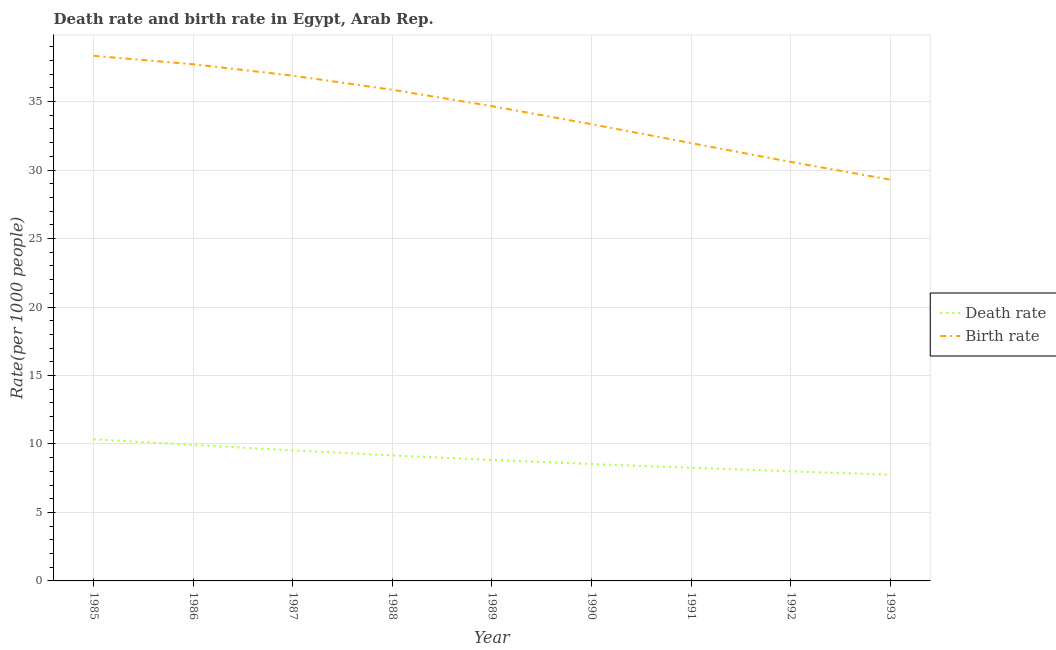Does the line corresponding to death rate intersect with the line corresponding to birth rate?
Make the answer very short. No. What is the birth rate in 1986?
Ensure brevity in your answer.  37.73. Across all years, what is the maximum death rate?
Provide a short and direct response. 10.34. Across all years, what is the minimum birth rate?
Give a very brief answer. 29.3. What is the total birth rate in the graph?
Offer a terse response. 308.69. What is the difference between the death rate in 1986 and that in 1990?
Your answer should be very brief. 1.39. What is the difference between the death rate in 1989 and the birth rate in 1985?
Your answer should be compact. -29.51. What is the average birth rate per year?
Give a very brief answer. 34.3. In the year 1992, what is the difference between the death rate and birth rate?
Offer a very short reply. -22.59. In how many years, is the death rate greater than 36?
Keep it short and to the point. 0. What is the ratio of the birth rate in 1991 to that in 1993?
Give a very brief answer. 1.09. Is the death rate in 1990 less than that in 1992?
Offer a very short reply. No. Is the difference between the birth rate in 1986 and 1991 greater than the difference between the death rate in 1986 and 1991?
Offer a terse response. Yes. What is the difference between the highest and the second highest birth rate?
Provide a short and direct response. 0.62. What is the difference between the highest and the lowest birth rate?
Keep it short and to the point. 9.05. Is the sum of the death rate in 1989 and 1993 greater than the maximum birth rate across all years?
Offer a very short reply. No. Does the death rate monotonically increase over the years?
Your answer should be compact. No. Is the death rate strictly greater than the birth rate over the years?
Offer a terse response. No. Does the graph contain any zero values?
Make the answer very short. No. Does the graph contain grids?
Keep it short and to the point. Yes. How many legend labels are there?
Provide a succinct answer. 2. What is the title of the graph?
Offer a very short reply. Death rate and birth rate in Egypt, Arab Rep. What is the label or title of the Y-axis?
Offer a very short reply. Rate(per 1000 people). What is the Rate(per 1000 people) in Death rate in 1985?
Your answer should be compact. 10.34. What is the Rate(per 1000 people) in Birth rate in 1985?
Offer a very short reply. 38.34. What is the Rate(per 1000 people) of Death rate in 1986?
Keep it short and to the point. 9.93. What is the Rate(per 1000 people) of Birth rate in 1986?
Your response must be concise. 37.73. What is the Rate(per 1000 people) in Death rate in 1987?
Offer a very short reply. 9.53. What is the Rate(per 1000 people) of Birth rate in 1987?
Your answer should be very brief. 36.89. What is the Rate(per 1000 people) in Death rate in 1988?
Provide a short and direct response. 9.16. What is the Rate(per 1000 people) of Birth rate in 1988?
Your answer should be compact. 35.86. What is the Rate(per 1000 people) of Death rate in 1989?
Provide a short and direct response. 8.83. What is the Rate(per 1000 people) of Birth rate in 1989?
Provide a short and direct response. 34.67. What is the Rate(per 1000 people) in Death rate in 1990?
Your answer should be compact. 8.54. What is the Rate(per 1000 people) of Birth rate in 1990?
Ensure brevity in your answer.  33.35. What is the Rate(per 1000 people) in Death rate in 1991?
Keep it short and to the point. 8.26. What is the Rate(per 1000 people) in Birth rate in 1991?
Your response must be concise. 31.97. What is the Rate(per 1000 people) in Death rate in 1992?
Keep it short and to the point. 8.01. What is the Rate(per 1000 people) of Birth rate in 1992?
Offer a very short reply. 30.59. What is the Rate(per 1000 people) of Death rate in 1993?
Make the answer very short. 7.75. What is the Rate(per 1000 people) of Birth rate in 1993?
Your answer should be compact. 29.3. Across all years, what is the maximum Rate(per 1000 people) in Death rate?
Keep it short and to the point. 10.34. Across all years, what is the maximum Rate(per 1000 people) in Birth rate?
Offer a very short reply. 38.34. Across all years, what is the minimum Rate(per 1000 people) of Death rate?
Offer a very short reply. 7.75. Across all years, what is the minimum Rate(per 1000 people) of Birth rate?
Ensure brevity in your answer.  29.3. What is the total Rate(per 1000 people) of Death rate in the graph?
Keep it short and to the point. 80.36. What is the total Rate(per 1000 people) of Birth rate in the graph?
Ensure brevity in your answer.  308.69. What is the difference between the Rate(per 1000 people) of Death rate in 1985 and that in 1986?
Your answer should be very brief. 0.41. What is the difference between the Rate(per 1000 people) of Birth rate in 1985 and that in 1986?
Offer a very short reply. 0.62. What is the difference between the Rate(per 1000 people) in Death rate in 1985 and that in 1987?
Keep it short and to the point. 0.81. What is the difference between the Rate(per 1000 people) in Birth rate in 1985 and that in 1987?
Offer a terse response. 1.45. What is the difference between the Rate(per 1000 people) of Death rate in 1985 and that in 1988?
Your response must be concise. 1.18. What is the difference between the Rate(per 1000 people) of Birth rate in 1985 and that in 1988?
Provide a succinct answer. 2.48. What is the difference between the Rate(per 1000 people) in Death rate in 1985 and that in 1989?
Give a very brief answer. 1.51. What is the difference between the Rate(per 1000 people) in Birth rate in 1985 and that in 1989?
Provide a succinct answer. 3.68. What is the difference between the Rate(per 1000 people) of Death rate in 1985 and that in 1990?
Your answer should be compact. 1.8. What is the difference between the Rate(per 1000 people) in Birth rate in 1985 and that in 1990?
Offer a terse response. 4.99. What is the difference between the Rate(per 1000 people) in Death rate in 1985 and that in 1991?
Your answer should be very brief. 2.08. What is the difference between the Rate(per 1000 people) of Birth rate in 1985 and that in 1991?
Keep it short and to the point. 6.38. What is the difference between the Rate(per 1000 people) of Death rate in 1985 and that in 1992?
Your answer should be compact. 2.33. What is the difference between the Rate(per 1000 people) in Birth rate in 1985 and that in 1992?
Offer a terse response. 7.75. What is the difference between the Rate(per 1000 people) in Death rate in 1985 and that in 1993?
Your answer should be very brief. 2.58. What is the difference between the Rate(per 1000 people) of Birth rate in 1985 and that in 1993?
Provide a succinct answer. 9.05. What is the difference between the Rate(per 1000 people) in Death rate in 1986 and that in 1987?
Give a very brief answer. 0.4. What is the difference between the Rate(per 1000 people) of Birth rate in 1986 and that in 1987?
Provide a short and direct response. 0.83. What is the difference between the Rate(per 1000 people) of Death rate in 1986 and that in 1988?
Offer a very short reply. 0.76. What is the difference between the Rate(per 1000 people) of Birth rate in 1986 and that in 1988?
Your response must be concise. 1.86. What is the difference between the Rate(per 1000 people) in Death rate in 1986 and that in 1989?
Ensure brevity in your answer.  1.09. What is the difference between the Rate(per 1000 people) of Birth rate in 1986 and that in 1989?
Your answer should be very brief. 3.06. What is the difference between the Rate(per 1000 people) of Death rate in 1986 and that in 1990?
Ensure brevity in your answer.  1.39. What is the difference between the Rate(per 1000 people) in Birth rate in 1986 and that in 1990?
Provide a succinct answer. 4.38. What is the difference between the Rate(per 1000 people) in Death rate in 1986 and that in 1991?
Your answer should be very brief. 1.66. What is the difference between the Rate(per 1000 people) in Birth rate in 1986 and that in 1991?
Your response must be concise. 5.76. What is the difference between the Rate(per 1000 people) of Death rate in 1986 and that in 1992?
Ensure brevity in your answer.  1.92. What is the difference between the Rate(per 1000 people) of Birth rate in 1986 and that in 1992?
Ensure brevity in your answer.  7.13. What is the difference between the Rate(per 1000 people) of Death rate in 1986 and that in 1993?
Offer a very short reply. 2.17. What is the difference between the Rate(per 1000 people) of Birth rate in 1986 and that in 1993?
Offer a very short reply. 8.43. What is the difference between the Rate(per 1000 people) in Death rate in 1987 and that in 1988?
Provide a succinct answer. 0.37. What is the difference between the Rate(per 1000 people) of Death rate in 1987 and that in 1989?
Your answer should be very brief. 0.7. What is the difference between the Rate(per 1000 people) in Birth rate in 1987 and that in 1989?
Make the answer very short. 2.23. What is the difference between the Rate(per 1000 people) in Death rate in 1987 and that in 1990?
Your answer should be very brief. 0.99. What is the difference between the Rate(per 1000 people) in Birth rate in 1987 and that in 1990?
Offer a very short reply. 3.54. What is the difference between the Rate(per 1000 people) in Death rate in 1987 and that in 1991?
Your answer should be very brief. 1.27. What is the difference between the Rate(per 1000 people) of Birth rate in 1987 and that in 1991?
Your response must be concise. 4.92. What is the difference between the Rate(per 1000 people) in Death rate in 1987 and that in 1992?
Offer a very short reply. 1.53. What is the difference between the Rate(per 1000 people) in Birth rate in 1987 and that in 1992?
Provide a short and direct response. 6.3. What is the difference between the Rate(per 1000 people) of Death rate in 1987 and that in 1993?
Provide a succinct answer. 1.78. What is the difference between the Rate(per 1000 people) in Birth rate in 1987 and that in 1993?
Provide a succinct answer. 7.6. What is the difference between the Rate(per 1000 people) of Death rate in 1988 and that in 1989?
Ensure brevity in your answer.  0.33. What is the difference between the Rate(per 1000 people) in Birth rate in 1988 and that in 1989?
Provide a short and direct response. 1.2. What is the difference between the Rate(per 1000 people) in Death rate in 1988 and that in 1990?
Provide a short and direct response. 0.63. What is the difference between the Rate(per 1000 people) of Birth rate in 1988 and that in 1990?
Your response must be concise. 2.51. What is the difference between the Rate(per 1000 people) in Death rate in 1988 and that in 1991?
Provide a succinct answer. 0.9. What is the difference between the Rate(per 1000 people) in Birth rate in 1988 and that in 1991?
Offer a very short reply. 3.9. What is the difference between the Rate(per 1000 people) in Death rate in 1988 and that in 1992?
Keep it short and to the point. 1.16. What is the difference between the Rate(per 1000 people) of Birth rate in 1988 and that in 1992?
Offer a very short reply. 5.27. What is the difference between the Rate(per 1000 people) of Death rate in 1988 and that in 1993?
Provide a succinct answer. 1.41. What is the difference between the Rate(per 1000 people) in Birth rate in 1988 and that in 1993?
Make the answer very short. 6.57. What is the difference between the Rate(per 1000 people) in Death rate in 1989 and that in 1990?
Provide a succinct answer. 0.3. What is the difference between the Rate(per 1000 people) of Birth rate in 1989 and that in 1990?
Keep it short and to the point. 1.32. What is the difference between the Rate(per 1000 people) of Death rate in 1989 and that in 1991?
Your answer should be very brief. 0.57. What is the difference between the Rate(per 1000 people) of Birth rate in 1989 and that in 1991?
Keep it short and to the point. 2.7. What is the difference between the Rate(per 1000 people) in Death rate in 1989 and that in 1992?
Your response must be concise. 0.83. What is the difference between the Rate(per 1000 people) of Birth rate in 1989 and that in 1992?
Ensure brevity in your answer.  4.07. What is the difference between the Rate(per 1000 people) of Death rate in 1989 and that in 1993?
Your response must be concise. 1.08. What is the difference between the Rate(per 1000 people) of Birth rate in 1989 and that in 1993?
Make the answer very short. 5.37. What is the difference between the Rate(per 1000 people) in Death rate in 1990 and that in 1991?
Provide a succinct answer. 0.27. What is the difference between the Rate(per 1000 people) of Birth rate in 1990 and that in 1991?
Give a very brief answer. 1.38. What is the difference between the Rate(per 1000 people) of Death rate in 1990 and that in 1992?
Your answer should be compact. 0.53. What is the difference between the Rate(per 1000 people) in Birth rate in 1990 and that in 1992?
Give a very brief answer. 2.75. What is the difference between the Rate(per 1000 people) of Death rate in 1990 and that in 1993?
Your response must be concise. 0.78. What is the difference between the Rate(per 1000 people) in Birth rate in 1990 and that in 1993?
Provide a succinct answer. 4.05. What is the difference between the Rate(per 1000 people) of Death rate in 1991 and that in 1992?
Offer a terse response. 0.26. What is the difference between the Rate(per 1000 people) of Birth rate in 1991 and that in 1992?
Give a very brief answer. 1.37. What is the difference between the Rate(per 1000 people) of Death rate in 1991 and that in 1993?
Your answer should be very brief. 0.51. What is the difference between the Rate(per 1000 people) of Birth rate in 1991 and that in 1993?
Your answer should be very brief. 2.67. What is the difference between the Rate(per 1000 people) of Death rate in 1992 and that in 1993?
Make the answer very short. 0.25. What is the difference between the Rate(per 1000 people) of Birth rate in 1992 and that in 1993?
Your answer should be compact. 1.3. What is the difference between the Rate(per 1000 people) of Death rate in 1985 and the Rate(per 1000 people) of Birth rate in 1986?
Offer a very short reply. -27.39. What is the difference between the Rate(per 1000 people) of Death rate in 1985 and the Rate(per 1000 people) of Birth rate in 1987?
Provide a succinct answer. -26.55. What is the difference between the Rate(per 1000 people) of Death rate in 1985 and the Rate(per 1000 people) of Birth rate in 1988?
Your response must be concise. -25.52. What is the difference between the Rate(per 1000 people) of Death rate in 1985 and the Rate(per 1000 people) of Birth rate in 1989?
Provide a short and direct response. -24.33. What is the difference between the Rate(per 1000 people) of Death rate in 1985 and the Rate(per 1000 people) of Birth rate in 1990?
Give a very brief answer. -23.01. What is the difference between the Rate(per 1000 people) of Death rate in 1985 and the Rate(per 1000 people) of Birth rate in 1991?
Your response must be concise. -21.63. What is the difference between the Rate(per 1000 people) of Death rate in 1985 and the Rate(per 1000 people) of Birth rate in 1992?
Keep it short and to the point. -20.25. What is the difference between the Rate(per 1000 people) in Death rate in 1985 and the Rate(per 1000 people) in Birth rate in 1993?
Offer a terse response. -18.96. What is the difference between the Rate(per 1000 people) in Death rate in 1986 and the Rate(per 1000 people) in Birth rate in 1987?
Provide a short and direct response. -26.97. What is the difference between the Rate(per 1000 people) of Death rate in 1986 and the Rate(per 1000 people) of Birth rate in 1988?
Ensure brevity in your answer.  -25.94. What is the difference between the Rate(per 1000 people) of Death rate in 1986 and the Rate(per 1000 people) of Birth rate in 1989?
Your response must be concise. -24.74. What is the difference between the Rate(per 1000 people) of Death rate in 1986 and the Rate(per 1000 people) of Birth rate in 1990?
Offer a very short reply. -23.42. What is the difference between the Rate(per 1000 people) in Death rate in 1986 and the Rate(per 1000 people) in Birth rate in 1991?
Provide a short and direct response. -22.04. What is the difference between the Rate(per 1000 people) of Death rate in 1986 and the Rate(per 1000 people) of Birth rate in 1992?
Your answer should be very brief. -20.67. What is the difference between the Rate(per 1000 people) in Death rate in 1986 and the Rate(per 1000 people) in Birth rate in 1993?
Give a very brief answer. -19.37. What is the difference between the Rate(per 1000 people) of Death rate in 1987 and the Rate(per 1000 people) of Birth rate in 1988?
Ensure brevity in your answer.  -26.33. What is the difference between the Rate(per 1000 people) in Death rate in 1987 and the Rate(per 1000 people) in Birth rate in 1989?
Provide a succinct answer. -25.14. What is the difference between the Rate(per 1000 people) in Death rate in 1987 and the Rate(per 1000 people) in Birth rate in 1990?
Your response must be concise. -23.82. What is the difference between the Rate(per 1000 people) in Death rate in 1987 and the Rate(per 1000 people) in Birth rate in 1991?
Offer a very short reply. -22.44. What is the difference between the Rate(per 1000 people) in Death rate in 1987 and the Rate(per 1000 people) in Birth rate in 1992?
Provide a succinct answer. -21.06. What is the difference between the Rate(per 1000 people) of Death rate in 1987 and the Rate(per 1000 people) of Birth rate in 1993?
Ensure brevity in your answer.  -19.77. What is the difference between the Rate(per 1000 people) of Death rate in 1988 and the Rate(per 1000 people) of Birth rate in 1989?
Your answer should be very brief. -25.5. What is the difference between the Rate(per 1000 people) of Death rate in 1988 and the Rate(per 1000 people) of Birth rate in 1990?
Provide a short and direct response. -24.18. What is the difference between the Rate(per 1000 people) of Death rate in 1988 and the Rate(per 1000 people) of Birth rate in 1991?
Offer a very short reply. -22.8. What is the difference between the Rate(per 1000 people) in Death rate in 1988 and the Rate(per 1000 people) in Birth rate in 1992?
Give a very brief answer. -21.43. What is the difference between the Rate(per 1000 people) of Death rate in 1988 and the Rate(per 1000 people) of Birth rate in 1993?
Provide a short and direct response. -20.13. What is the difference between the Rate(per 1000 people) in Death rate in 1989 and the Rate(per 1000 people) in Birth rate in 1990?
Give a very brief answer. -24.51. What is the difference between the Rate(per 1000 people) in Death rate in 1989 and the Rate(per 1000 people) in Birth rate in 1991?
Provide a short and direct response. -23.13. What is the difference between the Rate(per 1000 people) in Death rate in 1989 and the Rate(per 1000 people) in Birth rate in 1992?
Ensure brevity in your answer.  -21.76. What is the difference between the Rate(per 1000 people) in Death rate in 1989 and the Rate(per 1000 people) in Birth rate in 1993?
Your answer should be very brief. -20.46. What is the difference between the Rate(per 1000 people) of Death rate in 1990 and the Rate(per 1000 people) of Birth rate in 1991?
Ensure brevity in your answer.  -23.43. What is the difference between the Rate(per 1000 people) of Death rate in 1990 and the Rate(per 1000 people) of Birth rate in 1992?
Provide a succinct answer. -22.06. What is the difference between the Rate(per 1000 people) of Death rate in 1990 and the Rate(per 1000 people) of Birth rate in 1993?
Offer a terse response. -20.76. What is the difference between the Rate(per 1000 people) in Death rate in 1991 and the Rate(per 1000 people) in Birth rate in 1992?
Your answer should be very brief. -22.33. What is the difference between the Rate(per 1000 people) of Death rate in 1991 and the Rate(per 1000 people) of Birth rate in 1993?
Give a very brief answer. -21.03. What is the difference between the Rate(per 1000 people) in Death rate in 1992 and the Rate(per 1000 people) in Birth rate in 1993?
Ensure brevity in your answer.  -21.29. What is the average Rate(per 1000 people) of Death rate per year?
Give a very brief answer. 8.93. What is the average Rate(per 1000 people) of Birth rate per year?
Offer a terse response. 34.3. In the year 1985, what is the difference between the Rate(per 1000 people) in Death rate and Rate(per 1000 people) in Birth rate?
Ensure brevity in your answer.  -28. In the year 1986, what is the difference between the Rate(per 1000 people) in Death rate and Rate(per 1000 people) in Birth rate?
Ensure brevity in your answer.  -27.8. In the year 1987, what is the difference between the Rate(per 1000 people) in Death rate and Rate(per 1000 people) in Birth rate?
Offer a very short reply. -27.36. In the year 1988, what is the difference between the Rate(per 1000 people) of Death rate and Rate(per 1000 people) of Birth rate?
Offer a terse response. -26.7. In the year 1989, what is the difference between the Rate(per 1000 people) in Death rate and Rate(per 1000 people) in Birth rate?
Keep it short and to the point. -25.83. In the year 1990, what is the difference between the Rate(per 1000 people) in Death rate and Rate(per 1000 people) in Birth rate?
Your response must be concise. -24.81. In the year 1991, what is the difference between the Rate(per 1000 people) in Death rate and Rate(per 1000 people) in Birth rate?
Provide a succinct answer. -23.7. In the year 1992, what is the difference between the Rate(per 1000 people) in Death rate and Rate(per 1000 people) in Birth rate?
Your response must be concise. -22.59. In the year 1993, what is the difference between the Rate(per 1000 people) in Death rate and Rate(per 1000 people) in Birth rate?
Make the answer very short. -21.54. What is the ratio of the Rate(per 1000 people) in Death rate in 1985 to that in 1986?
Give a very brief answer. 1.04. What is the ratio of the Rate(per 1000 people) of Birth rate in 1985 to that in 1986?
Your answer should be very brief. 1.02. What is the ratio of the Rate(per 1000 people) of Death rate in 1985 to that in 1987?
Your answer should be compact. 1.08. What is the ratio of the Rate(per 1000 people) of Birth rate in 1985 to that in 1987?
Give a very brief answer. 1.04. What is the ratio of the Rate(per 1000 people) in Death rate in 1985 to that in 1988?
Ensure brevity in your answer.  1.13. What is the ratio of the Rate(per 1000 people) in Birth rate in 1985 to that in 1988?
Provide a succinct answer. 1.07. What is the ratio of the Rate(per 1000 people) of Death rate in 1985 to that in 1989?
Offer a very short reply. 1.17. What is the ratio of the Rate(per 1000 people) in Birth rate in 1985 to that in 1989?
Your answer should be compact. 1.11. What is the ratio of the Rate(per 1000 people) in Death rate in 1985 to that in 1990?
Your answer should be very brief. 1.21. What is the ratio of the Rate(per 1000 people) of Birth rate in 1985 to that in 1990?
Offer a terse response. 1.15. What is the ratio of the Rate(per 1000 people) of Death rate in 1985 to that in 1991?
Provide a succinct answer. 1.25. What is the ratio of the Rate(per 1000 people) in Birth rate in 1985 to that in 1991?
Provide a short and direct response. 1.2. What is the ratio of the Rate(per 1000 people) in Death rate in 1985 to that in 1992?
Offer a terse response. 1.29. What is the ratio of the Rate(per 1000 people) of Birth rate in 1985 to that in 1992?
Offer a terse response. 1.25. What is the ratio of the Rate(per 1000 people) of Birth rate in 1985 to that in 1993?
Provide a short and direct response. 1.31. What is the ratio of the Rate(per 1000 people) of Death rate in 1986 to that in 1987?
Offer a very short reply. 1.04. What is the ratio of the Rate(per 1000 people) in Birth rate in 1986 to that in 1987?
Your response must be concise. 1.02. What is the ratio of the Rate(per 1000 people) of Death rate in 1986 to that in 1988?
Your response must be concise. 1.08. What is the ratio of the Rate(per 1000 people) of Birth rate in 1986 to that in 1988?
Provide a short and direct response. 1.05. What is the ratio of the Rate(per 1000 people) of Death rate in 1986 to that in 1989?
Give a very brief answer. 1.12. What is the ratio of the Rate(per 1000 people) in Birth rate in 1986 to that in 1989?
Offer a terse response. 1.09. What is the ratio of the Rate(per 1000 people) of Death rate in 1986 to that in 1990?
Offer a very short reply. 1.16. What is the ratio of the Rate(per 1000 people) in Birth rate in 1986 to that in 1990?
Offer a very short reply. 1.13. What is the ratio of the Rate(per 1000 people) of Death rate in 1986 to that in 1991?
Make the answer very short. 1.2. What is the ratio of the Rate(per 1000 people) of Birth rate in 1986 to that in 1991?
Ensure brevity in your answer.  1.18. What is the ratio of the Rate(per 1000 people) of Death rate in 1986 to that in 1992?
Your answer should be compact. 1.24. What is the ratio of the Rate(per 1000 people) in Birth rate in 1986 to that in 1992?
Give a very brief answer. 1.23. What is the ratio of the Rate(per 1000 people) in Death rate in 1986 to that in 1993?
Ensure brevity in your answer.  1.28. What is the ratio of the Rate(per 1000 people) of Birth rate in 1986 to that in 1993?
Offer a terse response. 1.29. What is the ratio of the Rate(per 1000 people) of Death rate in 1987 to that in 1988?
Offer a terse response. 1.04. What is the ratio of the Rate(per 1000 people) in Birth rate in 1987 to that in 1988?
Make the answer very short. 1.03. What is the ratio of the Rate(per 1000 people) in Death rate in 1987 to that in 1989?
Provide a short and direct response. 1.08. What is the ratio of the Rate(per 1000 people) of Birth rate in 1987 to that in 1989?
Provide a short and direct response. 1.06. What is the ratio of the Rate(per 1000 people) in Death rate in 1987 to that in 1990?
Keep it short and to the point. 1.12. What is the ratio of the Rate(per 1000 people) of Birth rate in 1987 to that in 1990?
Your answer should be very brief. 1.11. What is the ratio of the Rate(per 1000 people) in Death rate in 1987 to that in 1991?
Your answer should be very brief. 1.15. What is the ratio of the Rate(per 1000 people) in Birth rate in 1987 to that in 1991?
Your response must be concise. 1.15. What is the ratio of the Rate(per 1000 people) of Death rate in 1987 to that in 1992?
Provide a succinct answer. 1.19. What is the ratio of the Rate(per 1000 people) of Birth rate in 1987 to that in 1992?
Offer a terse response. 1.21. What is the ratio of the Rate(per 1000 people) in Death rate in 1987 to that in 1993?
Provide a succinct answer. 1.23. What is the ratio of the Rate(per 1000 people) in Birth rate in 1987 to that in 1993?
Your response must be concise. 1.26. What is the ratio of the Rate(per 1000 people) in Death rate in 1988 to that in 1989?
Give a very brief answer. 1.04. What is the ratio of the Rate(per 1000 people) of Birth rate in 1988 to that in 1989?
Ensure brevity in your answer.  1.03. What is the ratio of the Rate(per 1000 people) of Death rate in 1988 to that in 1990?
Keep it short and to the point. 1.07. What is the ratio of the Rate(per 1000 people) in Birth rate in 1988 to that in 1990?
Provide a short and direct response. 1.08. What is the ratio of the Rate(per 1000 people) of Death rate in 1988 to that in 1991?
Offer a very short reply. 1.11. What is the ratio of the Rate(per 1000 people) of Birth rate in 1988 to that in 1991?
Ensure brevity in your answer.  1.12. What is the ratio of the Rate(per 1000 people) of Death rate in 1988 to that in 1992?
Provide a succinct answer. 1.14. What is the ratio of the Rate(per 1000 people) in Birth rate in 1988 to that in 1992?
Ensure brevity in your answer.  1.17. What is the ratio of the Rate(per 1000 people) in Death rate in 1988 to that in 1993?
Give a very brief answer. 1.18. What is the ratio of the Rate(per 1000 people) in Birth rate in 1988 to that in 1993?
Offer a terse response. 1.22. What is the ratio of the Rate(per 1000 people) of Death rate in 1989 to that in 1990?
Provide a short and direct response. 1.03. What is the ratio of the Rate(per 1000 people) in Birth rate in 1989 to that in 1990?
Provide a succinct answer. 1.04. What is the ratio of the Rate(per 1000 people) in Death rate in 1989 to that in 1991?
Your answer should be compact. 1.07. What is the ratio of the Rate(per 1000 people) in Birth rate in 1989 to that in 1991?
Give a very brief answer. 1.08. What is the ratio of the Rate(per 1000 people) of Death rate in 1989 to that in 1992?
Your answer should be compact. 1.1. What is the ratio of the Rate(per 1000 people) in Birth rate in 1989 to that in 1992?
Ensure brevity in your answer.  1.13. What is the ratio of the Rate(per 1000 people) in Death rate in 1989 to that in 1993?
Your answer should be compact. 1.14. What is the ratio of the Rate(per 1000 people) in Birth rate in 1989 to that in 1993?
Provide a short and direct response. 1.18. What is the ratio of the Rate(per 1000 people) of Death rate in 1990 to that in 1991?
Make the answer very short. 1.03. What is the ratio of the Rate(per 1000 people) of Birth rate in 1990 to that in 1991?
Keep it short and to the point. 1.04. What is the ratio of the Rate(per 1000 people) of Death rate in 1990 to that in 1992?
Your response must be concise. 1.07. What is the ratio of the Rate(per 1000 people) of Birth rate in 1990 to that in 1992?
Offer a very short reply. 1.09. What is the ratio of the Rate(per 1000 people) in Death rate in 1990 to that in 1993?
Provide a short and direct response. 1.1. What is the ratio of the Rate(per 1000 people) of Birth rate in 1990 to that in 1993?
Provide a short and direct response. 1.14. What is the ratio of the Rate(per 1000 people) of Death rate in 1991 to that in 1992?
Your answer should be compact. 1.03. What is the ratio of the Rate(per 1000 people) in Birth rate in 1991 to that in 1992?
Provide a succinct answer. 1.04. What is the ratio of the Rate(per 1000 people) in Death rate in 1991 to that in 1993?
Offer a very short reply. 1.07. What is the ratio of the Rate(per 1000 people) in Birth rate in 1991 to that in 1993?
Make the answer very short. 1.09. What is the ratio of the Rate(per 1000 people) in Death rate in 1992 to that in 1993?
Your response must be concise. 1.03. What is the ratio of the Rate(per 1000 people) in Birth rate in 1992 to that in 1993?
Make the answer very short. 1.04. What is the difference between the highest and the second highest Rate(per 1000 people) in Death rate?
Your answer should be compact. 0.41. What is the difference between the highest and the second highest Rate(per 1000 people) of Birth rate?
Your answer should be compact. 0.62. What is the difference between the highest and the lowest Rate(per 1000 people) of Death rate?
Keep it short and to the point. 2.58. What is the difference between the highest and the lowest Rate(per 1000 people) of Birth rate?
Give a very brief answer. 9.05. 